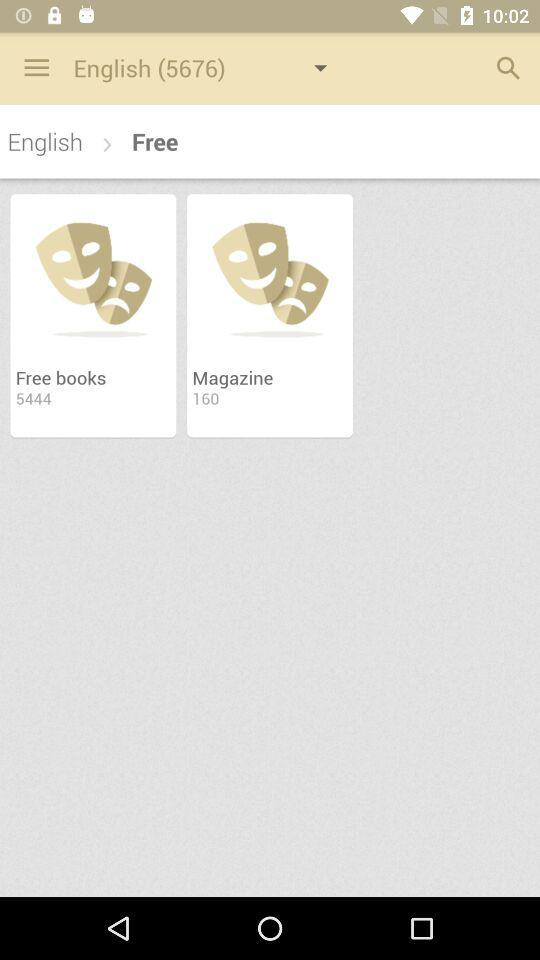Which language options are available in the drop-down menu?
When the provided information is insufficient, respond with <no answer>. <no answer> 